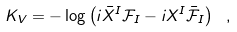<formula> <loc_0><loc_0><loc_500><loc_500>K _ { V } = - \log \left ( i \bar { X } ^ { I } \mathcal { F } _ { I } - i X ^ { I } \bar { \mathcal { F } } _ { I } \right ) \ ,</formula> 